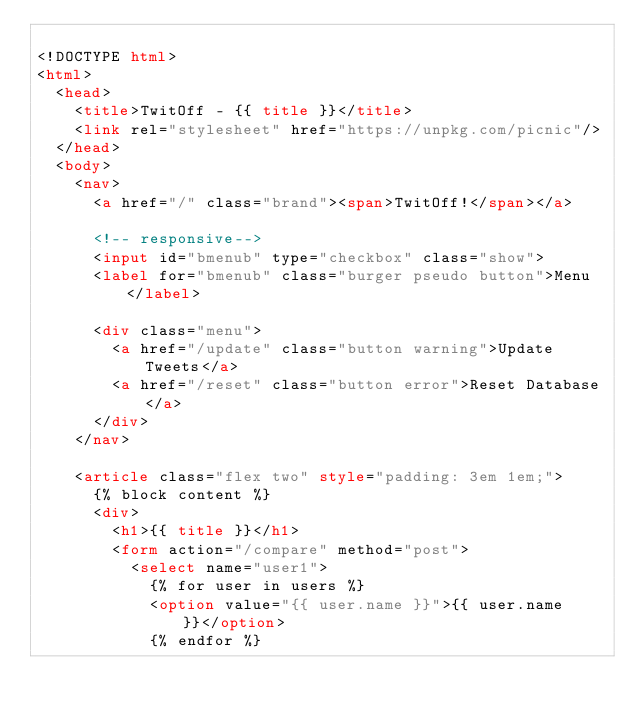<code> <loc_0><loc_0><loc_500><loc_500><_HTML_>
<!DOCTYPE html>
<html>
  <head>
    <title>TwitOff - {{ title }}</title>
    <link rel="stylesheet" href="https://unpkg.com/picnic"/>
  </head>
  <body>
    <nav>
      <a href="/" class="brand"><span>TwitOff!</span></a>

      <!-- responsive-->
      <input id="bmenub" type="checkbox" class="show">
      <label for="bmenub" class="burger pseudo button">Menu</label>

      <div class="menu">
        <a href="/update" class="button warning">Update Tweets</a>
        <a href="/reset" class="button error">Reset Database</a>
      </div>
    </nav>

    <article class="flex two" style="padding: 3em 1em;">
      {% block content %}
      <div>
        <h1>{{ title }}</h1>
        <form action="/compare" method="post">
          <select name="user1">
            {% for user in users %}
            <option value="{{ user.name }}">{{ user.name }}</option>
            {% endfor %}</code> 